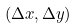<formula> <loc_0><loc_0><loc_500><loc_500>( \Delta x , \Delta y )</formula> 